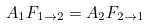<formula> <loc_0><loc_0><loc_500><loc_500>A _ { 1 } F _ { 1 \rightarrow 2 } = A _ { 2 } F _ { 2 \rightarrow 1 }</formula> 